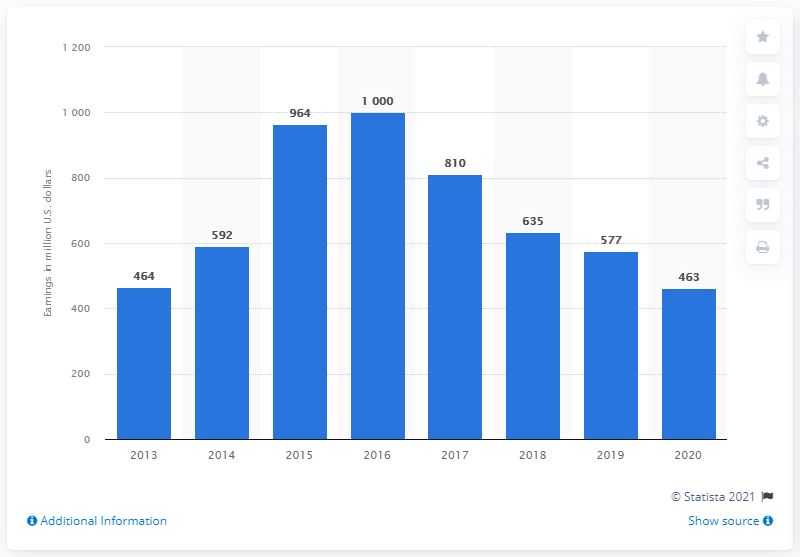List a handful of essential elements in this visual. Supercell's pre-tax earnings in the previous year were 577. Supercell's pre-tax earnings in the United States in 2020 were approximately $463 million. 